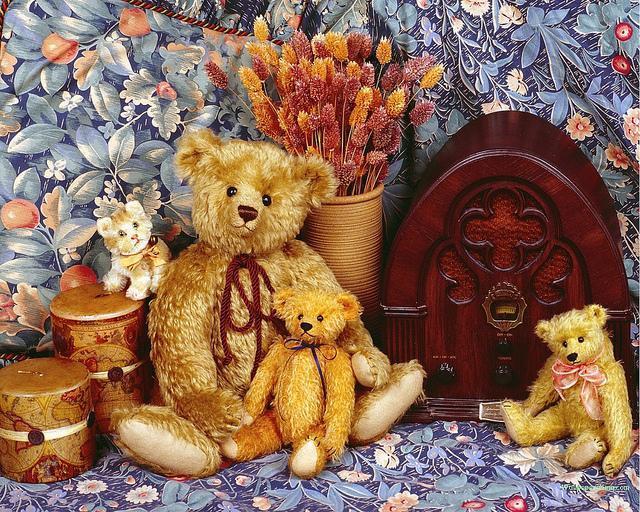How many teddy bears are there?
Give a very brief answer. 4. 